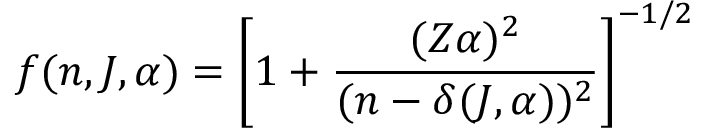<formula> <loc_0><loc_0><loc_500><loc_500>f ( n , J , \alpha ) = \left [ 1 + \frac { ( Z \alpha ) ^ { 2 } } { ( n - \delta ( J , \alpha ) ) ^ { 2 } } \right ] ^ { - 1 / 2 }</formula> 